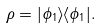<formula> <loc_0><loc_0><loc_500><loc_500>\rho = | \phi _ { 1 } \rangle \langle \phi _ { 1 } | .</formula> 